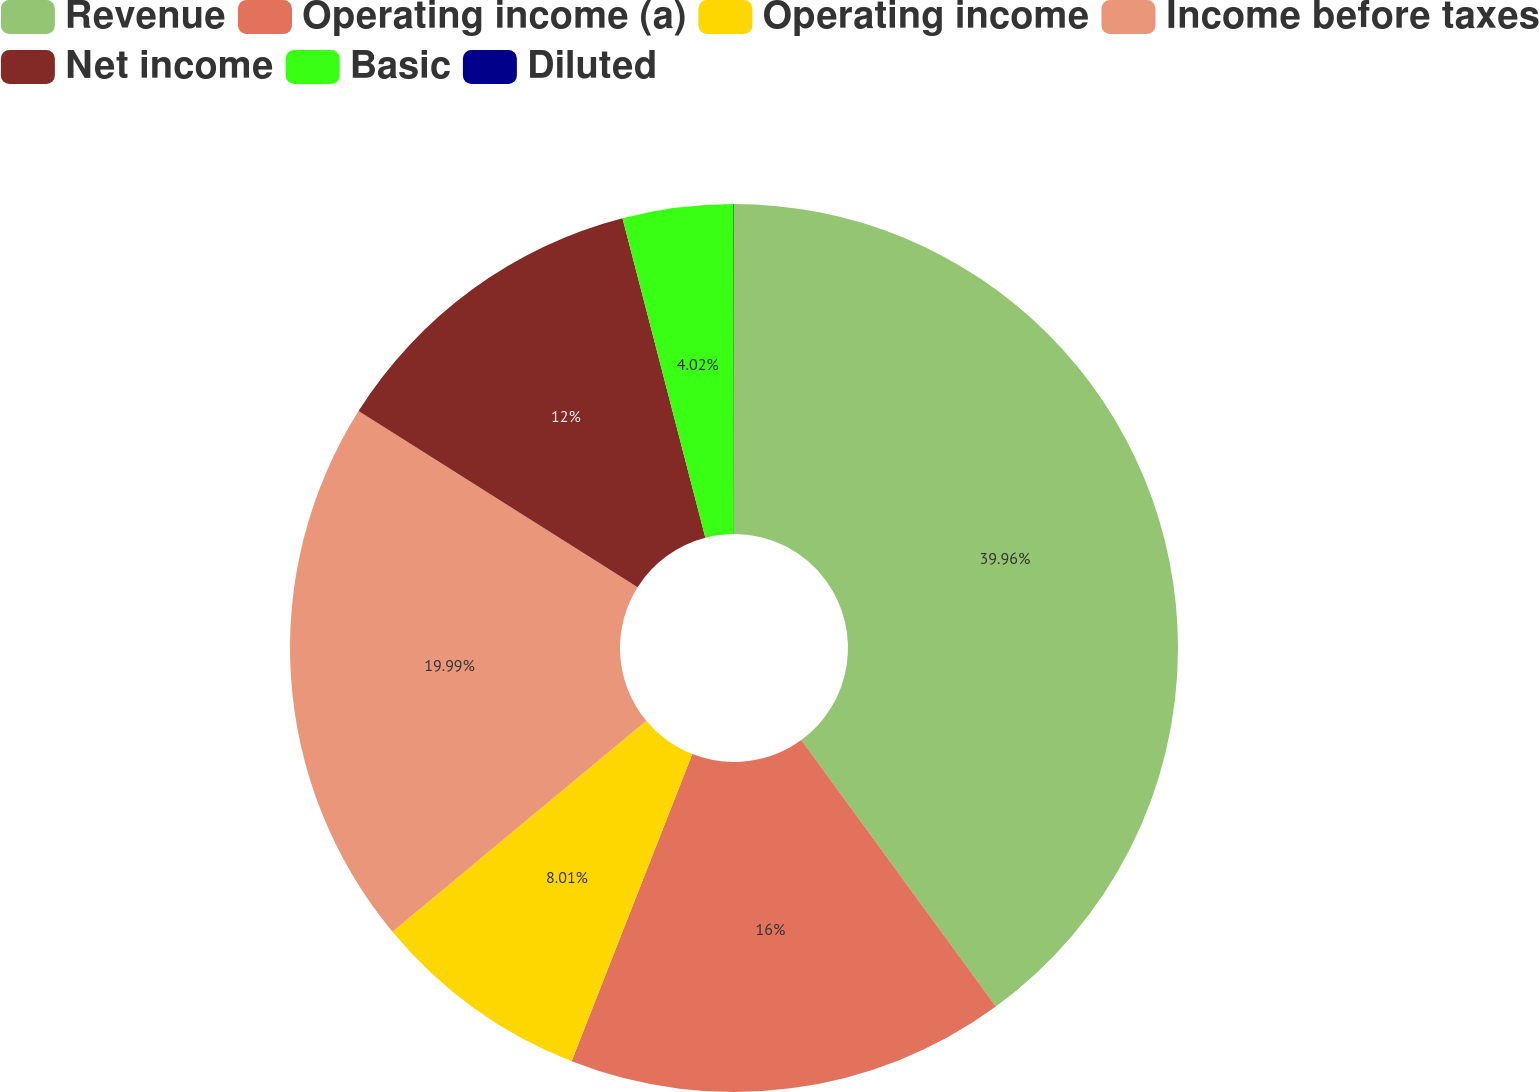Convert chart. <chart><loc_0><loc_0><loc_500><loc_500><pie_chart><fcel>Revenue<fcel>Operating income (a)<fcel>Operating income<fcel>Income before taxes<fcel>Net income<fcel>Basic<fcel>Diluted<nl><fcel>39.96%<fcel>16.0%<fcel>8.01%<fcel>19.99%<fcel>12.0%<fcel>4.02%<fcel>0.02%<nl></chart> 